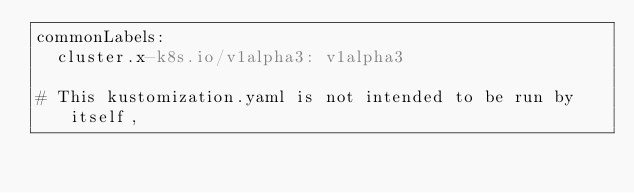<code> <loc_0><loc_0><loc_500><loc_500><_YAML_>commonLabels:
  cluster.x-k8s.io/v1alpha3: v1alpha3

# This kustomization.yaml is not intended to be run by itself,</code> 